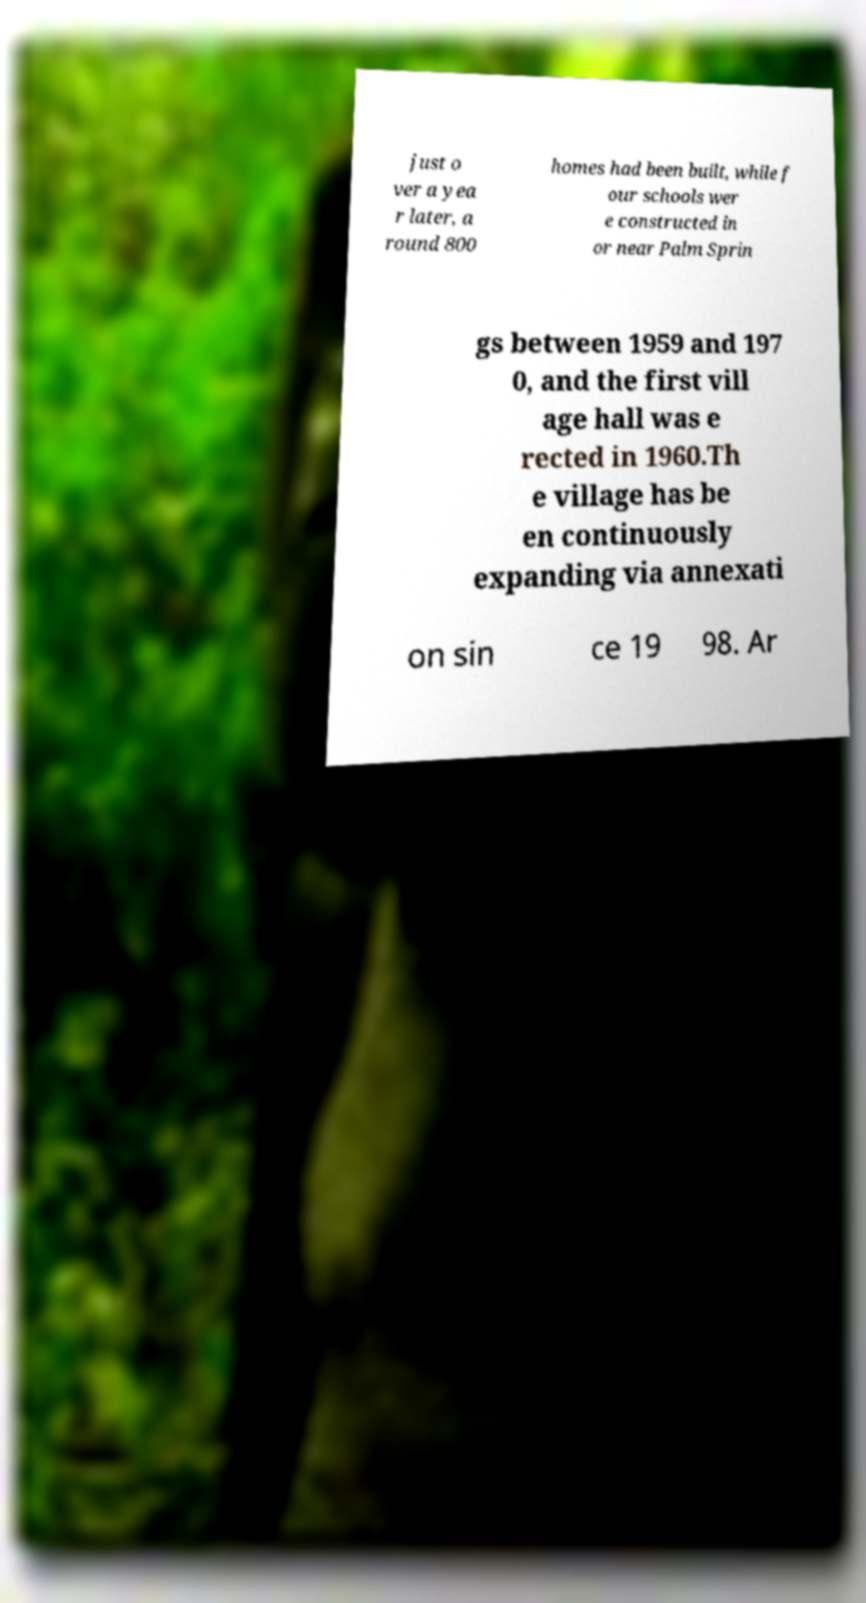For documentation purposes, I need the text within this image transcribed. Could you provide that? just o ver a yea r later, a round 800 homes had been built, while f our schools wer e constructed in or near Palm Sprin gs between 1959 and 197 0, and the first vill age hall was e rected in 1960.Th e village has be en continuously expanding via annexati on sin ce 19 98. Ar 